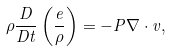Convert formula to latex. <formula><loc_0><loc_0><loc_500><loc_500>\rho \frac { D } { D t } \left ( \frac { e } { \rho } \right ) = - P \nabla \cdot v ,</formula> 